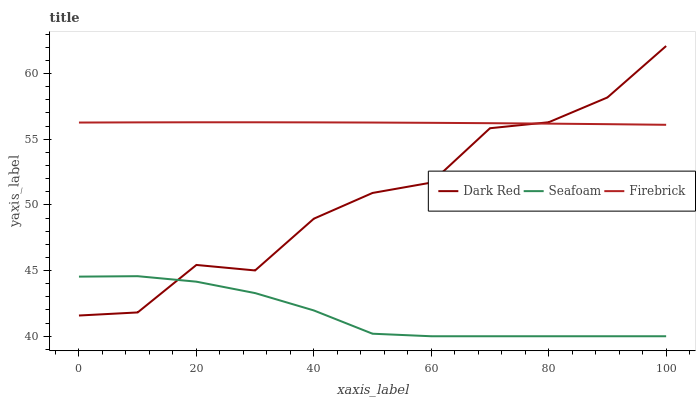Does Seafoam have the minimum area under the curve?
Answer yes or no. Yes. Does Firebrick have the maximum area under the curve?
Answer yes or no. Yes. Does Firebrick have the minimum area under the curve?
Answer yes or no. No. Does Seafoam have the maximum area under the curve?
Answer yes or no. No. Is Firebrick the smoothest?
Answer yes or no. Yes. Is Dark Red the roughest?
Answer yes or no. Yes. Is Seafoam the smoothest?
Answer yes or no. No. Is Seafoam the roughest?
Answer yes or no. No. Does Firebrick have the lowest value?
Answer yes or no. No. Does Dark Red have the highest value?
Answer yes or no. Yes. Does Firebrick have the highest value?
Answer yes or no. No. Is Seafoam less than Firebrick?
Answer yes or no. Yes. Is Firebrick greater than Seafoam?
Answer yes or no. Yes. Does Dark Red intersect Seafoam?
Answer yes or no. Yes. Is Dark Red less than Seafoam?
Answer yes or no. No. Is Dark Red greater than Seafoam?
Answer yes or no. No. Does Seafoam intersect Firebrick?
Answer yes or no. No. 